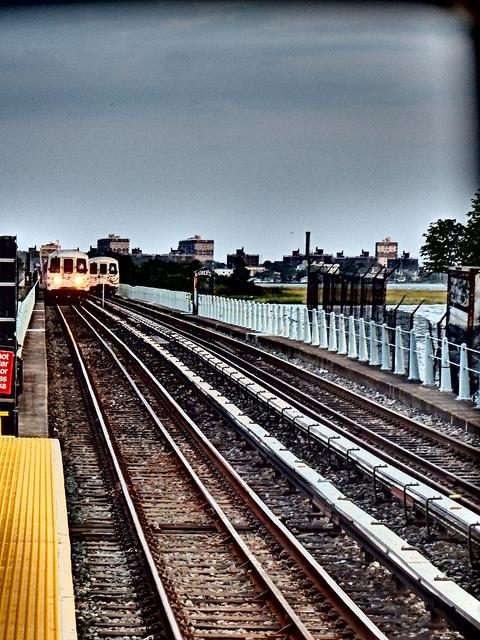Are there people on the train?
Keep it brief. Yes. Is the train on the left arriving or departing?
Short answer required. Arriving. How many train tracks are there?
Give a very brief answer. 2. 